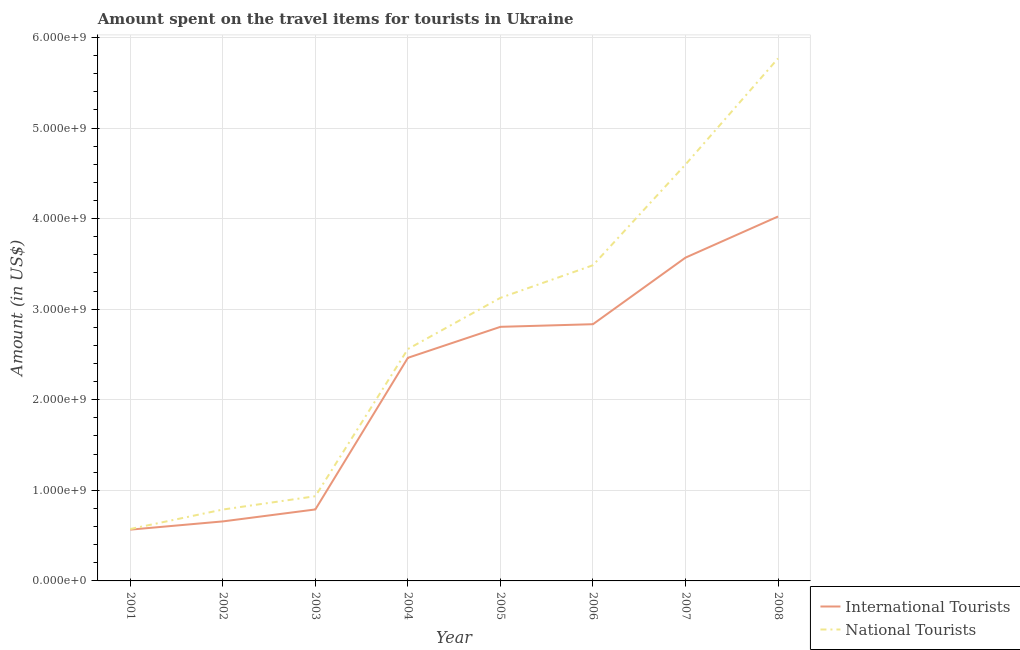How many different coloured lines are there?
Your response must be concise. 2. Does the line corresponding to amount spent on travel items of national tourists intersect with the line corresponding to amount spent on travel items of international tourists?
Keep it short and to the point. No. Is the number of lines equal to the number of legend labels?
Your response must be concise. Yes. What is the amount spent on travel items of national tourists in 2006?
Make the answer very short. 3.48e+09. Across all years, what is the maximum amount spent on travel items of international tourists?
Give a very brief answer. 4.02e+09. Across all years, what is the minimum amount spent on travel items of national tourists?
Offer a very short reply. 5.73e+08. In which year was the amount spent on travel items of international tourists maximum?
Give a very brief answer. 2008. In which year was the amount spent on travel items of national tourists minimum?
Offer a terse response. 2001. What is the total amount spent on travel items of national tourists in the graph?
Offer a very short reply. 2.18e+1. What is the difference between the amount spent on travel items of international tourists in 2001 and that in 2008?
Give a very brief answer. -3.46e+09. What is the difference between the amount spent on travel items of international tourists in 2006 and the amount spent on travel items of national tourists in 2008?
Provide a short and direct response. -2.93e+09. What is the average amount spent on travel items of national tourists per year?
Your response must be concise. 2.73e+09. In the year 2005, what is the difference between the amount spent on travel items of national tourists and amount spent on travel items of international tourists?
Make the answer very short. 3.20e+08. What is the ratio of the amount spent on travel items of international tourists in 2005 to that in 2008?
Give a very brief answer. 0.7. Is the amount spent on travel items of international tourists in 2006 less than that in 2007?
Keep it short and to the point. Yes. What is the difference between the highest and the second highest amount spent on travel items of international tourists?
Provide a short and direct response. 4.54e+08. What is the difference between the highest and the lowest amount spent on travel items of national tourists?
Your answer should be very brief. 5.20e+09. Does the amount spent on travel items of international tourists monotonically increase over the years?
Give a very brief answer. Yes. Is the amount spent on travel items of international tourists strictly less than the amount spent on travel items of national tourists over the years?
Give a very brief answer. Yes. How many years are there in the graph?
Your response must be concise. 8. What is the difference between two consecutive major ticks on the Y-axis?
Offer a very short reply. 1.00e+09. Are the values on the major ticks of Y-axis written in scientific E-notation?
Provide a short and direct response. Yes. Where does the legend appear in the graph?
Give a very brief answer. Bottom right. How many legend labels are there?
Provide a succinct answer. 2. What is the title of the graph?
Keep it short and to the point. Amount spent on the travel items for tourists in Ukraine. What is the Amount (in US$) of International Tourists in 2001?
Your response must be concise. 5.66e+08. What is the Amount (in US$) of National Tourists in 2001?
Offer a terse response. 5.73e+08. What is the Amount (in US$) in International Tourists in 2002?
Your answer should be compact. 6.57e+08. What is the Amount (in US$) in National Tourists in 2002?
Provide a short and direct response. 7.88e+08. What is the Amount (in US$) in International Tourists in 2003?
Your answer should be very brief. 7.89e+08. What is the Amount (in US$) of National Tourists in 2003?
Offer a very short reply. 9.35e+08. What is the Amount (in US$) of International Tourists in 2004?
Provide a succinct answer. 2.46e+09. What is the Amount (in US$) of National Tourists in 2004?
Your answer should be compact. 2.56e+09. What is the Amount (in US$) in International Tourists in 2005?
Offer a terse response. 2.80e+09. What is the Amount (in US$) of National Tourists in 2005?
Keep it short and to the point. 3.12e+09. What is the Amount (in US$) in International Tourists in 2006?
Offer a very short reply. 2.83e+09. What is the Amount (in US$) of National Tourists in 2006?
Your answer should be compact. 3.48e+09. What is the Amount (in US$) of International Tourists in 2007?
Your response must be concise. 3.57e+09. What is the Amount (in US$) in National Tourists in 2007?
Keep it short and to the point. 4.60e+09. What is the Amount (in US$) of International Tourists in 2008?
Your response must be concise. 4.02e+09. What is the Amount (in US$) of National Tourists in 2008?
Provide a succinct answer. 5.77e+09. Across all years, what is the maximum Amount (in US$) of International Tourists?
Your answer should be compact. 4.02e+09. Across all years, what is the maximum Amount (in US$) of National Tourists?
Make the answer very short. 5.77e+09. Across all years, what is the minimum Amount (in US$) of International Tourists?
Your answer should be very brief. 5.66e+08. Across all years, what is the minimum Amount (in US$) of National Tourists?
Your response must be concise. 5.73e+08. What is the total Amount (in US$) of International Tourists in the graph?
Your answer should be compact. 1.77e+1. What is the total Amount (in US$) of National Tourists in the graph?
Offer a terse response. 2.18e+1. What is the difference between the Amount (in US$) in International Tourists in 2001 and that in 2002?
Give a very brief answer. -9.10e+07. What is the difference between the Amount (in US$) of National Tourists in 2001 and that in 2002?
Provide a short and direct response. -2.15e+08. What is the difference between the Amount (in US$) of International Tourists in 2001 and that in 2003?
Your answer should be compact. -2.23e+08. What is the difference between the Amount (in US$) of National Tourists in 2001 and that in 2003?
Your answer should be compact. -3.62e+08. What is the difference between the Amount (in US$) of International Tourists in 2001 and that in 2004?
Your answer should be compact. -1.90e+09. What is the difference between the Amount (in US$) of National Tourists in 2001 and that in 2004?
Offer a terse response. -1.99e+09. What is the difference between the Amount (in US$) of International Tourists in 2001 and that in 2005?
Keep it short and to the point. -2.24e+09. What is the difference between the Amount (in US$) in National Tourists in 2001 and that in 2005?
Your response must be concise. -2.55e+09. What is the difference between the Amount (in US$) in International Tourists in 2001 and that in 2006?
Provide a short and direct response. -2.27e+09. What is the difference between the Amount (in US$) in National Tourists in 2001 and that in 2006?
Your answer should be compact. -2.91e+09. What is the difference between the Amount (in US$) in International Tourists in 2001 and that in 2007?
Your answer should be compact. -3.00e+09. What is the difference between the Amount (in US$) in National Tourists in 2001 and that in 2007?
Provide a succinct answer. -4.02e+09. What is the difference between the Amount (in US$) of International Tourists in 2001 and that in 2008?
Your answer should be compact. -3.46e+09. What is the difference between the Amount (in US$) of National Tourists in 2001 and that in 2008?
Your response must be concise. -5.20e+09. What is the difference between the Amount (in US$) of International Tourists in 2002 and that in 2003?
Make the answer very short. -1.32e+08. What is the difference between the Amount (in US$) of National Tourists in 2002 and that in 2003?
Your answer should be very brief. -1.47e+08. What is the difference between the Amount (in US$) in International Tourists in 2002 and that in 2004?
Keep it short and to the point. -1.81e+09. What is the difference between the Amount (in US$) of National Tourists in 2002 and that in 2004?
Provide a short and direct response. -1.77e+09. What is the difference between the Amount (in US$) in International Tourists in 2002 and that in 2005?
Provide a short and direct response. -2.15e+09. What is the difference between the Amount (in US$) of National Tourists in 2002 and that in 2005?
Offer a very short reply. -2.34e+09. What is the difference between the Amount (in US$) in International Tourists in 2002 and that in 2006?
Offer a very short reply. -2.18e+09. What is the difference between the Amount (in US$) in National Tourists in 2002 and that in 2006?
Provide a short and direct response. -2.70e+09. What is the difference between the Amount (in US$) in International Tourists in 2002 and that in 2007?
Make the answer very short. -2.91e+09. What is the difference between the Amount (in US$) in National Tourists in 2002 and that in 2007?
Make the answer very short. -3.81e+09. What is the difference between the Amount (in US$) of International Tourists in 2002 and that in 2008?
Provide a short and direct response. -3.37e+09. What is the difference between the Amount (in US$) in National Tourists in 2002 and that in 2008?
Provide a succinct answer. -4.98e+09. What is the difference between the Amount (in US$) in International Tourists in 2003 and that in 2004?
Keep it short and to the point. -1.67e+09. What is the difference between the Amount (in US$) in National Tourists in 2003 and that in 2004?
Your answer should be compact. -1.62e+09. What is the difference between the Amount (in US$) in International Tourists in 2003 and that in 2005?
Make the answer very short. -2.02e+09. What is the difference between the Amount (in US$) in National Tourists in 2003 and that in 2005?
Ensure brevity in your answer.  -2.19e+09. What is the difference between the Amount (in US$) in International Tourists in 2003 and that in 2006?
Your answer should be compact. -2.04e+09. What is the difference between the Amount (in US$) in National Tourists in 2003 and that in 2006?
Offer a very short reply. -2.55e+09. What is the difference between the Amount (in US$) of International Tourists in 2003 and that in 2007?
Provide a short and direct response. -2.78e+09. What is the difference between the Amount (in US$) in National Tourists in 2003 and that in 2007?
Offer a very short reply. -3.66e+09. What is the difference between the Amount (in US$) in International Tourists in 2003 and that in 2008?
Keep it short and to the point. -3.23e+09. What is the difference between the Amount (in US$) of National Tourists in 2003 and that in 2008?
Your answer should be compact. -4.83e+09. What is the difference between the Amount (in US$) of International Tourists in 2004 and that in 2005?
Keep it short and to the point. -3.42e+08. What is the difference between the Amount (in US$) in National Tourists in 2004 and that in 2005?
Offer a very short reply. -5.65e+08. What is the difference between the Amount (in US$) in International Tourists in 2004 and that in 2006?
Your answer should be compact. -3.71e+08. What is the difference between the Amount (in US$) of National Tourists in 2004 and that in 2006?
Your answer should be very brief. -9.25e+08. What is the difference between the Amount (in US$) of International Tourists in 2004 and that in 2007?
Your response must be concise. -1.11e+09. What is the difference between the Amount (in US$) in National Tourists in 2004 and that in 2007?
Your answer should be compact. -2.04e+09. What is the difference between the Amount (in US$) in International Tourists in 2004 and that in 2008?
Offer a terse response. -1.56e+09. What is the difference between the Amount (in US$) in National Tourists in 2004 and that in 2008?
Your answer should be compact. -3.21e+09. What is the difference between the Amount (in US$) in International Tourists in 2005 and that in 2006?
Your answer should be compact. -2.90e+07. What is the difference between the Amount (in US$) in National Tourists in 2005 and that in 2006?
Your answer should be very brief. -3.60e+08. What is the difference between the Amount (in US$) of International Tourists in 2005 and that in 2007?
Provide a succinct answer. -7.64e+08. What is the difference between the Amount (in US$) in National Tourists in 2005 and that in 2007?
Make the answer very short. -1.47e+09. What is the difference between the Amount (in US$) of International Tourists in 2005 and that in 2008?
Provide a succinct answer. -1.22e+09. What is the difference between the Amount (in US$) of National Tourists in 2005 and that in 2008?
Your answer should be compact. -2.64e+09. What is the difference between the Amount (in US$) in International Tourists in 2006 and that in 2007?
Your answer should be compact. -7.35e+08. What is the difference between the Amount (in US$) in National Tourists in 2006 and that in 2007?
Give a very brief answer. -1.11e+09. What is the difference between the Amount (in US$) of International Tourists in 2006 and that in 2008?
Make the answer very short. -1.19e+09. What is the difference between the Amount (in US$) of National Tourists in 2006 and that in 2008?
Provide a short and direct response. -2.28e+09. What is the difference between the Amount (in US$) in International Tourists in 2007 and that in 2008?
Provide a short and direct response. -4.54e+08. What is the difference between the Amount (in US$) in National Tourists in 2007 and that in 2008?
Your response must be concise. -1.17e+09. What is the difference between the Amount (in US$) of International Tourists in 2001 and the Amount (in US$) of National Tourists in 2002?
Keep it short and to the point. -2.22e+08. What is the difference between the Amount (in US$) of International Tourists in 2001 and the Amount (in US$) of National Tourists in 2003?
Your answer should be very brief. -3.69e+08. What is the difference between the Amount (in US$) in International Tourists in 2001 and the Amount (in US$) in National Tourists in 2004?
Your answer should be compact. -1.99e+09. What is the difference between the Amount (in US$) in International Tourists in 2001 and the Amount (in US$) in National Tourists in 2005?
Your answer should be compact. -2.56e+09. What is the difference between the Amount (in US$) in International Tourists in 2001 and the Amount (in US$) in National Tourists in 2006?
Your answer should be compact. -2.92e+09. What is the difference between the Amount (in US$) in International Tourists in 2001 and the Amount (in US$) in National Tourists in 2007?
Provide a short and direct response. -4.03e+09. What is the difference between the Amount (in US$) of International Tourists in 2001 and the Amount (in US$) of National Tourists in 2008?
Provide a succinct answer. -5.20e+09. What is the difference between the Amount (in US$) in International Tourists in 2002 and the Amount (in US$) in National Tourists in 2003?
Ensure brevity in your answer.  -2.78e+08. What is the difference between the Amount (in US$) of International Tourists in 2002 and the Amount (in US$) of National Tourists in 2004?
Your response must be concise. -1.90e+09. What is the difference between the Amount (in US$) in International Tourists in 2002 and the Amount (in US$) in National Tourists in 2005?
Give a very brief answer. -2.47e+09. What is the difference between the Amount (in US$) of International Tourists in 2002 and the Amount (in US$) of National Tourists in 2006?
Give a very brief answer. -2.83e+09. What is the difference between the Amount (in US$) in International Tourists in 2002 and the Amount (in US$) in National Tourists in 2007?
Offer a terse response. -3.94e+09. What is the difference between the Amount (in US$) of International Tourists in 2002 and the Amount (in US$) of National Tourists in 2008?
Make the answer very short. -5.11e+09. What is the difference between the Amount (in US$) of International Tourists in 2003 and the Amount (in US$) of National Tourists in 2004?
Your answer should be very brief. -1.77e+09. What is the difference between the Amount (in US$) of International Tourists in 2003 and the Amount (in US$) of National Tourists in 2005?
Offer a very short reply. -2.34e+09. What is the difference between the Amount (in US$) of International Tourists in 2003 and the Amount (in US$) of National Tourists in 2006?
Your answer should be compact. -2.70e+09. What is the difference between the Amount (in US$) in International Tourists in 2003 and the Amount (in US$) in National Tourists in 2007?
Keep it short and to the point. -3.81e+09. What is the difference between the Amount (in US$) in International Tourists in 2003 and the Amount (in US$) in National Tourists in 2008?
Your answer should be compact. -4.98e+09. What is the difference between the Amount (in US$) in International Tourists in 2004 and the Amount (in US$) in National Tourists in 2005?
Keep it short and to the point. -6.62e+08. What is the difference between the Amount (in US$) of International Tourists in 2004 and the Amount (in US$) of National Tourists in 2006?
Make the answer very short. -1.02e+09. What is the difference between the Amount (in US$) in International Tourists in 2004 and the Amount (in US$) in National Tourists in 2007?
Offer a terse response. -2.13e+09. What is the difference between the Amount (in US$) in International Tourists in 2004 and the Amount (in US$) in National Tourists in 2008?
Ensure brevity in your answer.  -3.30e+09. What is the difference between the Amount (in US$) in International Tourists in 2005 and the Amount (in US$) in National Tourists in 2006?
Give a very brief answer. -6.80e+08. What is the difference between the Amount (in US$) in International Tourists in 2005 and the Amount (in US$) in National Tourists in 2007?
Your answer should be compact. -1.79e+09. What is the difference between the Amount (in US$) in International Tourists in 2005 and the Amount (in US$) in National Tourists in 2008?
Your answer should be very brief. -2.96e+09. What is the difference between the Amount (in US$) in International Tourists in 2006 and the Amount (in US$) in National Tourists in 2007?
Your answer should be very brief. -1.76e+09. What is the difference between the Amount (in US$) of International Tourists in 2006 and the Amount (in US$) of National Tourists in 2008?
Keep it short and to the point. -2.93e+09. What is the difference between the Amount (in US$) in International Tourists in 2007 and the Amount (in US$) in National Tourists in 2008?
Make the answer very short. -2.20e+09. What is the average Amount (in US$) of International Tourists per year?
Offer a terse response. 2.21e+09. What is the average Amount (in US$) in National Tourists per year?
Offer a very short reply. 2.73e+09. In the year 2001, what is the difference between the Amount (in US$) of International Tourists and Amount (in US$) of National Tourists?
Keep it short and to the point. -7.00e+06. In the year 2002, what is the difference between the Amount (in US$) of International Tourists and Amount (in US$) of National Tourists?
Offer a terse response. -1.31e+08. In the year 2003, what is the difference between the Amount (in US$) of International Tourists and Amount (in US$) of National Tourists?
Make the answer very short. -1.46e+08. In the year 2004, what is the difference between the Amount (in US$) of International Tourists and Amount (in US$) of National Tourists?
Ensure brevity in your answer.  -9.70e+07. In the year 2005, what is the difference between the Amount (in US$) of International Tourists and Amount (in US$) of National Tourists?
Keep it short and to the point. -3.20e+08. In the year 2006, what is the difference between the Amount (in US$) in International Tourists and Amount (in US$) in National Tourists?
Your answer should be very brief. -6.51e+08. In the year 2007, what is the difference between the Amount (in US$) of International Tourists and Amount (in US$) of National Tourists?
Your answer should be compact. -1.03e+09. In the year 2008, what is the difference between the Amount (in US$) in International Tourists and Amount (in US$) in National Tourists?
Make the answer very short. -1.74e+09. What is the ratio of the Amount (in US$) of International Tourists in 2001 to that in 2002?
Give a very brief answer. 0.86. What is the ratio of the Amount (in US$) of National Tourists in 2001 to that in 2002?
Keep it short and to the point. 0.73. What is the ratio of the Amount (in US$) of International Tourists in 2001 to that in 2003?
Provide a succinct answer. 0.72. What is the ratio of the Amount (in US$) of National Tourists in 2001 to that in 2003?
Ensure brevity in your answer.  0.61. What is the ratio of the Amount (in US$) in International Tourists in 2001 to that in 2004?
Keep it short and to the point. 0.23. What is the ratio of the Amount (in US$) of National Tourists in 2001 to that in 2004?
Offer a terse response. 0.22. What is the ratio of the Amount (in US$) in International Tourists in 2001 to that in 2005?
Offer a terse response. 0.2. What is the ratio of the Amount (in US$) in National Tourists in 2001 to that in 2005?
Your answer should be compact. 0.18. What is the ratio of the Amount (in US$) in International Tourists in 2001 to that in 2006?
Your response must be concise. 0.2. What is the ratio of the Amount (in US$) in National Tourists in 2001 to that in 2006?
Offer a terse response. 0.16. What is the ratio of the Amount (in US$) of International Tourists in 2001 to that in 2007?
Offer a very short reply. 0.16. What is the ratio of the Amount (in US$) of National Tourists in 2001 to that in 2007?
Your response must be concise. 0.12. What is the ratio of the Amount (in US$) of International Tourists in 2001 to that in 2008?
Offer a very short reply. 0.14. What is the ratio of the Amount (in US$) of National Tourists in 2001 to that in 2008?
Make the answer very short. 0.1. What is the ratio of the Amount (in US$) in International Tourists in 2002 to that in 2003?
Your response must be concise. 0.83. What is the ratio of the Amount (in US$) of National Tourists in 2002 to that in 2003?
Your answer should be compact. 0.84. What is the ratio of the Amount (in US$) of International Tourists in 2002 to that in 2004?
Ensure brevity in your answer.  0.27. What is the ratio of the Amount (in US$) of National Tourists in 2002 to that in 2004?
Offer a terse response. 0.31. What is the ratio of the Amount (in US$) of International Tourists in 2002 to that in 2005?
Provide a succinct answer. 0.23. What is the ratio of the Amount (in US$) of National Tourists in 2002 to that in 2005?
Provide a short and direct response. 0.25. What is the ratio of the Amount (in US$) in International Tourists in 2002 to that in 2006?
Provide a succinct answer. 0.23. What is the ratio of the Amount (in US$) of National Tourists in 2002 to that in 2006?
Offer a terse response. 0.23. What is the ratio of the Amount (in US$) in International Tourists in 2002 to that in 2007?
Provide a short and direct response. 0.18. What is the ratio of the Amount (in US$) of National Tourists in 2002 to that in 2007?
Ensure brevity in your answer.  0.17. What is the ratio of the Amount (in US$) of International Tourists in 2002 to that in 2008?
Offer a terse response. 0.16. What is the ratio of the Amount (in US$) in National Tourists in 2002 to that in 2008?
Your answer should be very brief. 0.14. What is the ratio of the Amount (in US$) of International Tourists in 2003 to that in 2004?
Make the answer very short. 0.32. What is the ratio of the Amount (in US$) of National Tourists in 2003 to that in 2004?
Give a very brief answer. 0.37. What is the ratio of the Amount (in US$) in International Tourists in 2003 to that in 2005?
Offer a terse response. 0.28. What is the ratio of the Amount (in US$) of National Tourists in 2003 to that in 2005?
Your answer should be compact. 0.3. What is the ratio of the Amount (in US$) in International Tourists in 2003 to that in 2006?
Your answer should be compact. 0.28. What is the ratio of the Amount (in US$) in National Tourists in 2003 to that in 2006?
Give a very brief answer. 0.27. What is the ratio of the Amount (in US$) of International Tourists in 2003 to that in 2007?
Offer a terse response. 0.22. What is the ratio of the Amount (in US$) in National Tourists in 2003 to that in 2007?
Give a very brief answer. 0.2. What is the ratio of the Amount (in US$) of International Tourists in 2003 to that in 2008?
Keep it short and to the point. 0.2. What is the ratio of the Amount (in US$) of National Tourists in 2003 to that in 2008?
Keep it short and to the point. 0.16. What is the ratio of the Amount (in US$) in International Tourists in 2004 to that in 2005?
Make the answer very short. 0.88. What is the ratio of the Amount (in US$) of National Tourists in 2004 to that in 2005?
Your answer should be compact. 0.82. What is the ratio of the Amount (in US$) in International Tourists in 2004 to that in 2006?
Keep it short and to the point. 0.87. What is the ratio of the Amount (in US$) of National Tourists in 2004 to that in 2006?
Give a very brief answer. 0.73. What is the ratio of the Amount (in US$) in International Tourists in 2004 to that in 2007?
Make the answer very short. 0.69. What is the ratio of the Amount (in US$) of National Tourists in 2004 to that in 2007?
Make the answer very short. 0.56. What is the ratio of the Amount (in US$) of International Tourists in 2004 to that in 2008?
Ensure brevity in your answer.  0.61. What is the ratio of the Amount (in US$) in National Tourists in 2004 to that in 2008?
Offer a very short reply. 0.44. What is the ratio of the Amount (in US$) of International Tourists in 2005 to that in 2006?
Your answer should be compact. 0.99. What is the ratio of the Amount (in US$) of National Tourists in 2005 to that in 2006?
Provide a succinct answer. 0.9. What is the ratio of the Amount (in US$) in International Tourists in 2005 to that in 2007?
Your response must be concise. 0.79. What is the ratio of the Amount (in US$) of National Tourists in 2005 to that in 2007?
Provide a short and direct response. 0.68. What is the ratio of the Amount (in US$) in International Tourists in 2005 to that in 2008?
Offer a very short reply. 0.7. What is the ratio of the Amount (in US$) of National Tourists in 2005 to that in 2008?
Your answer should be very brief. 0.54. What is the ratio of the Amount (in US$) of International Tourists in 2006 to that in 2007?
Provide a short and direct response. 0.79. What is the ratio of the Amount (in US$) in National Tourists in 2006 to that in 2007?
Offer a terse response. 0.76. What is the ratio of the Amount (in US$) in International Tourists in 2006 to that in 2008?
Your response must be concise. 0.7. What is the ratio of the Amount (in US$) in National Tourists in 2006 to that in 2008?
Your response must be concise. 0.6. What is the ratio of the Amount (in US$) of International Tourists in 2007 to that in 2008?
Offer a very short reply. 0.89. What is the ratio of the Amount (in US$) in National Tourists in 2007 to that in 2008?
Provide a short and direct response. 0.8. What is the difference between the highest and the second highest Amount (in US$) in International Tourists?
Keep it short and to the point. 4.54e+08. What is the difference between the highest and the second highest Amount (in US$) in National Tourists?
Provide a succinct answer. 1.17e+09. What is the difference between the highest and the lowest Amount (in US$) of International Tourists?
Keep it short and to the point. 3.46e+09. What is the difference between the highest and the lowest Amount (in US$) in National Tourists?
Give a very brief answer. 5.20e+09. 